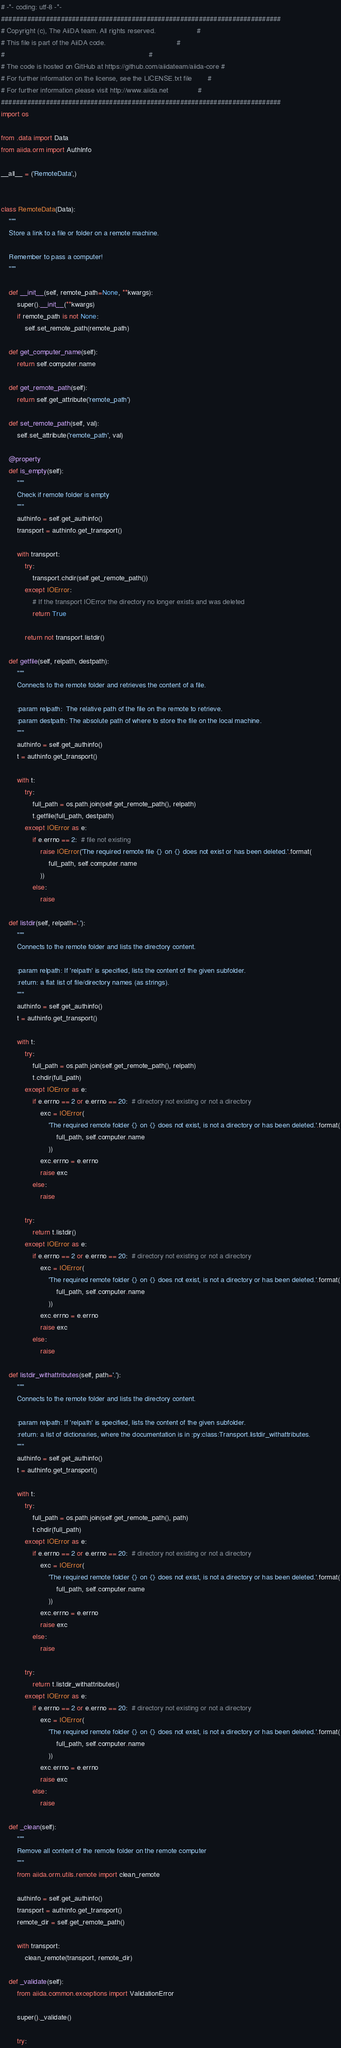<code> <loc_0><loc_0><loc_500><loc_500><_Python_># -*- coding: utf-8 -*-
###########################################################################
# Copyright (c), The AiiDA team. All rights reserved.                     #
# This file is part of the AiiDA code.                                    #
#                                                                         #
# The code is hosted on GitHub at https://github.com/aiidateam/aiida-core #
# For further information on the license, see the LICENSE.txt file        #
# For further information please visit http://www.aiida.net               #
###########################################################################
import os

from .data import Data
from aiida.orm import AuthInfo

__all__ = ('RemoteData',)


class RemoteData(Data):
    """
    Store a link to a file or folder on a remote machine.

    Remember to pass a computer!
    """

    def __init__(self, remote_path=None, **kwargs):
        super().__init__(**kwargs)
        if remote_path is not None:
            self.set_remote_path(remote_path)

    def get_computer_name(self):
        return self.computer.name

    def get_remote_path(self):
        return self.get_attribute('remote_path')

    def set_remote_path(self, val):
        self.set_attribute('remote_path', val)

    @property
    def is_empty(self):
        """
        Check if remote folder is empty
        """
        authinfo = self.get_authinfo()
        transport = authinfo.get_transport()

        with transport:
            try:
                transport.chdir(self.get_remote_path())
            except IOError:
                # If the transport IOError the directory no longer exists and was deleted
                return True

            return not transport.listdir()

    def getfile(self, relpath, destpath):
        """
        Connects to the remote folder and retrieves the content of a file.

        :param relpath:  The relative path of the file on the remote to retrieve.
        :param destpath: The absolute path of where to store the file on the local machine.
        """
        authinfo = self.get_authinfo()
        t = authinfo.get_transport()

        with t:
            try:
                full_path = os.path.join(self.get_remote_path(), relpath)
                t.getfile(full_path, destpath)
            except IOError as e:
                if e.errno == 2:  # file not existing
                    raise IOError('The required remote file {} on {} does not exist or has been deleted.'.format(
                        full_path, self.computer.name
                    ))
                else:
                    raise

    def listdir(self, relpath='.'):
        """
        Connects to the remote folder and lists the directory content.

        :param relpath: If 'relpath' is specified, lists the content of the given subfolder.
        :return: a flat list of file/directory names (as strings).
        """
        authinfo = self.get_authinfo()
        t = authinfo.get_transport()

        with t:
            try:
                full_path = os.path.join(self.get_remote_path(), relpath)
                t.chdir(full_path)
            except IOError as e:
                if e.errno == 2 or e.errno == 20:  # directory not existing or not a directory
                    exc = IOError(
                        'The required remote folder {} on {} does not exist, is not a directory or has been deleted.'.format(
                            full_path, self.computer.name
                        ))
                    exc.errno = e.errno
                    raise exc
                else:
                    raise

            try:
                return t.listdir()
            except IOError as e:
                if e.errno == 2 or e.errno == 20:  # directory not existing or not a directory
                    exc = IOError(
                        'The required remote folder {} on {} does not exist, is not a directory or has been deleted.'.format(
                            full_path, self.computer.name
                        ))
                    exc.errno = e.errno
                    raise exc
                else:
                    raise

    def listdir_withattributes(self, path='.'):
        """
        Connects to the remote folder and lists the directory content.

        :param relpath: If 'relpath' is specified, lists the content of the given subfolder.
        :return: a list of dictionaries, where the documentation is in :py:class:Transport.listdir_withattributes.
        """
        authinfo = self.get_authinfo()
        t = authinfo.get_transport()

        with t:
            try:
                full_path = os.path.join(self.get_remote_path(), path)
                t.chdir(full_path)
            except IOError as e:
                if e.errno == 2 or e.errno == 20:  # directory not existing or not a directory
                    exc = IOError(
                        'The required remote folder {} on {} does not exist, is not a directory or has been deleted.'.format(
                            full_path, self.computer.name
                        ))
                    exc.errno = e.errno
                    raise exc
                else:
                    raise

            try:
                return t.listdir_withattributes()
            except IOError as e:
                if e.errno == 2 or e.errno == 20:  # directory not existing or not a directory
                    exc = IOError(
                        'The required remote folder {} on {} does not exist, is not a directory or has been deleted.'.format(
                            full_path, self.computer.name
                        ))
                    exc.errno = e.errno
                    raise exc
                else:
                    raise

    def _clean(self):
        """
        Remove all content of the remote folder on the remote computer
        """
        from aiida.orm.utils.remote import clean_remote

        authinfo = self.get_authinfo()
        transport = authinfo.get_transport()
        remote_dir = self.get_remote_path()

        with transport:
            clean_remote(transport, remote_dir)

    def _validate(self):
        from aiida.common.exceptions import ValidationError

        super()._validate()

        try:</code> 